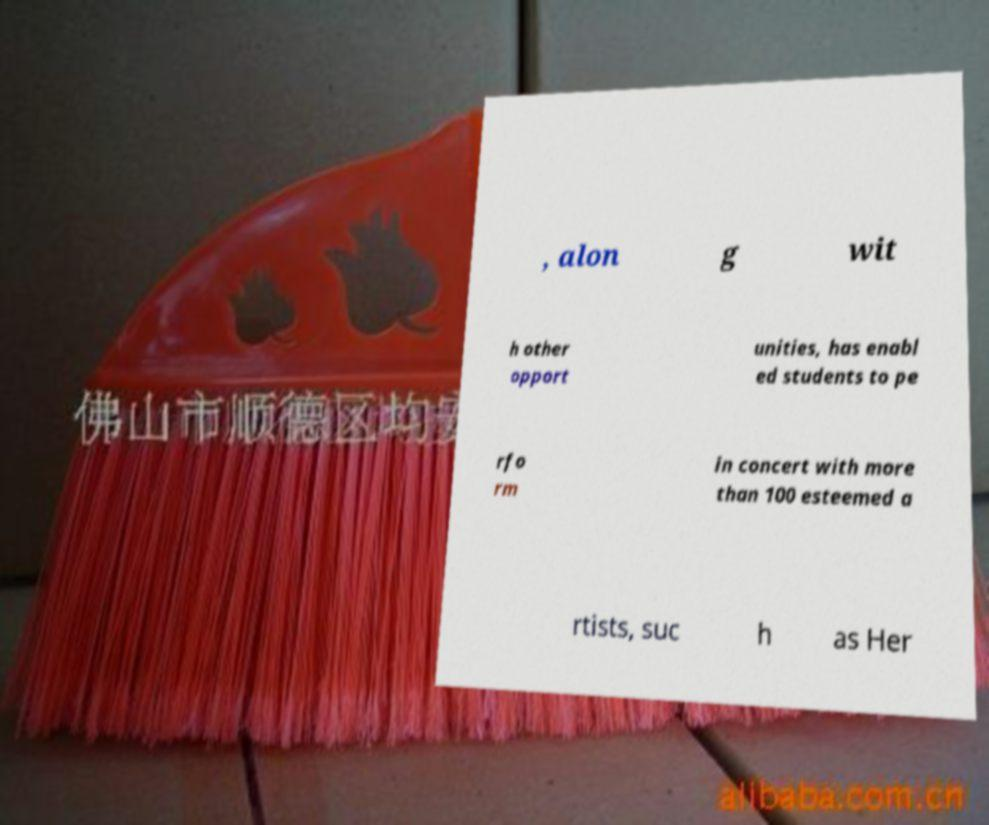I need the written content from this picture converted into text. Can you do that? , alon g wit h other opport unities, has enabl ed students to pe rfo rm in concert with more than 100 esteemed a rtists, suc h as Her 